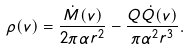Convert formula to latex. <formula><loc_0><loc_0><loc_500><loc_500>\rho ( v ) = \frac { \dot { M } ( v ) } { 2 \pi \alpha r ^ { 2 } } - \frac { Q \dot { Q } ( v ) } { \pi \alpha ^ { 2 } r ^ { 3 } } .</formula> 